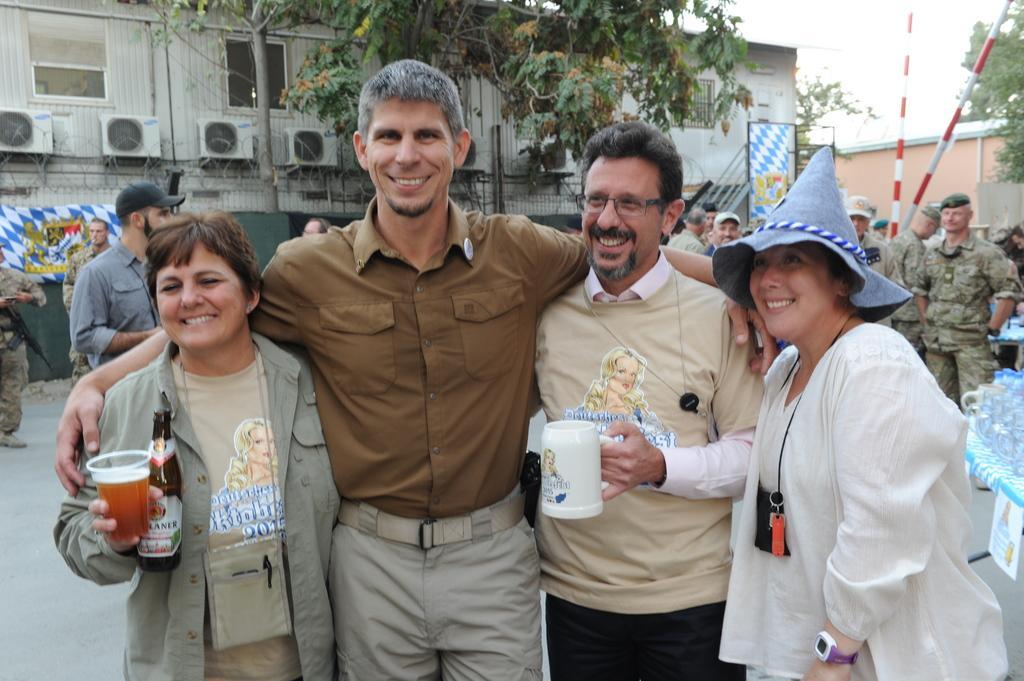Can you describe this image briefly? Here in this picture in the front we can see a group of people standing on the road and all of them are smiling and two persons are holding cups in their hands and the woman on the right side is wearing a cap and behind them also we can see number of people standing over there and we can see some people are wearing military dress with cap on them and we can also see poles present and we can also see a building with windows and AC present and we can see plants and trees present and we can see the sky is clear. 